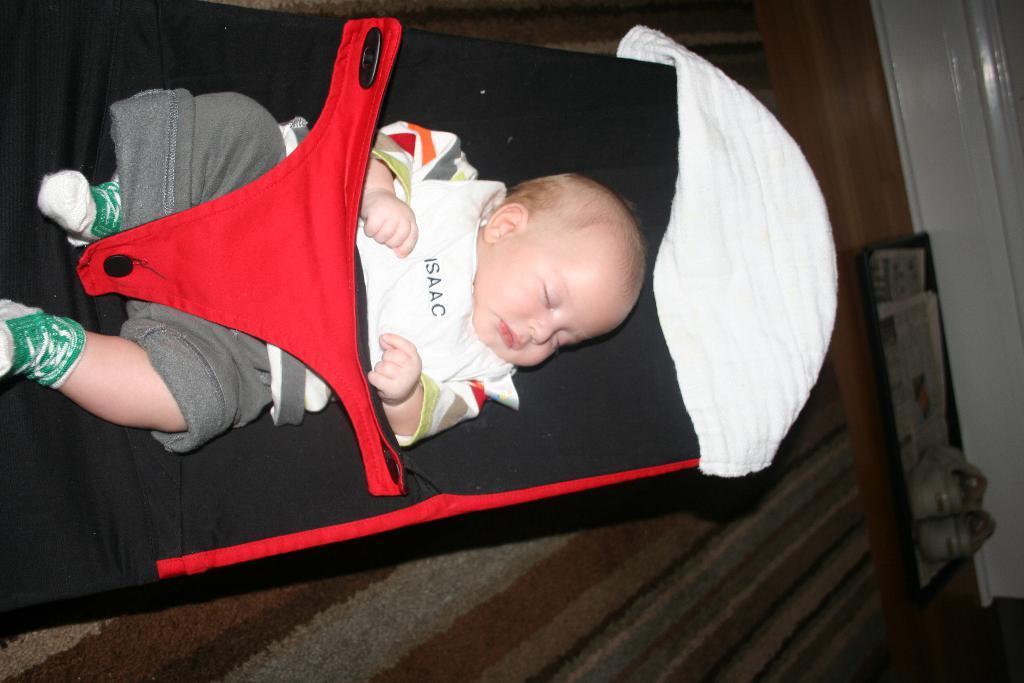Please provide a concise description of this image. In the image we can see a baby wearing clothes, socks and the baby is sleeping. Here we can see the shoes and the floor. 